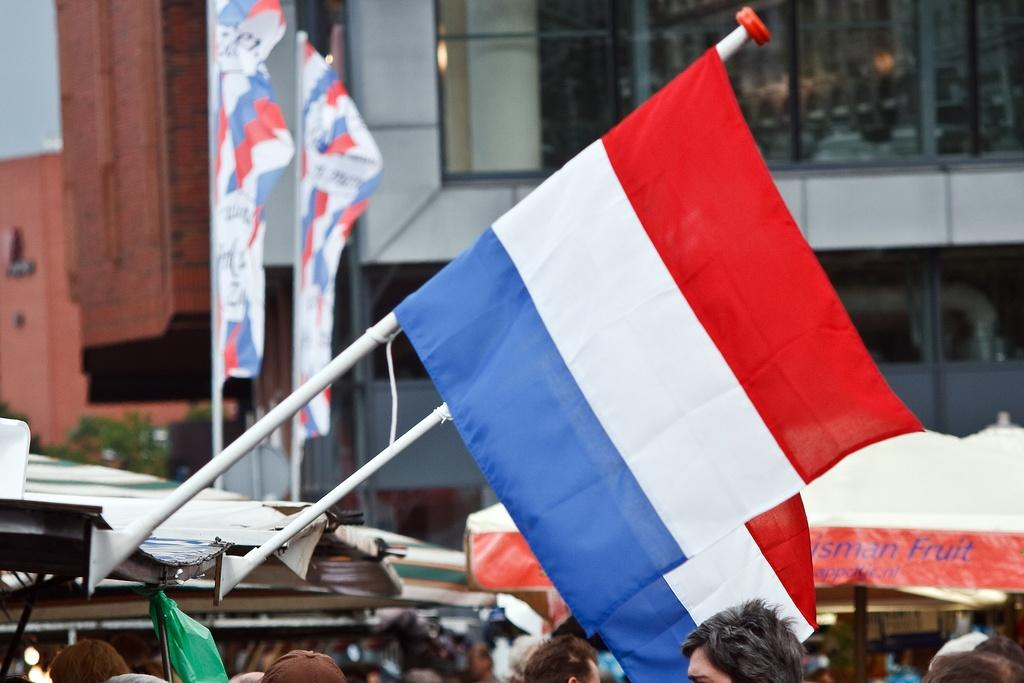What can be seen flying in the image? There are flags in the image. What type of temporary shelter is present in the image? There are tents in the image. Who or what is present in the image? There are people in the image. What type of vegetation can be seen in the image? There are trees in the image. What type of man-made structures are visible in the image? There are buildings in the image. Where is the prison located in the image? There is no prison present in the image. What type of lipstick is being used by the people in the image? There is no lipstick or any indication of makeup in the image. 